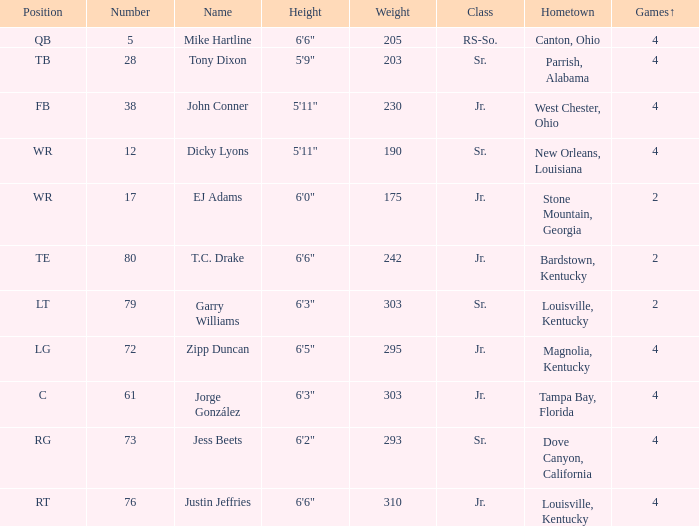Which group has a heaviness of 203? Sr. 